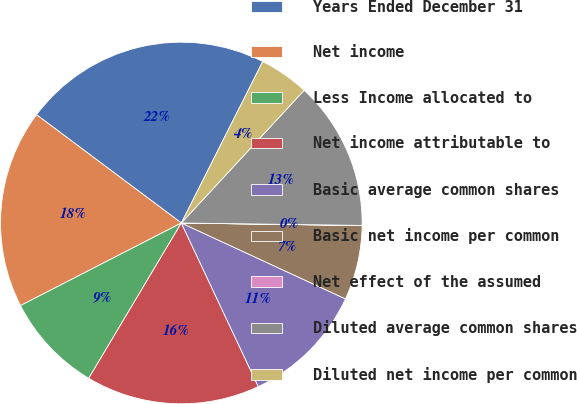Convert chart to OTSL. <chart><loc_0><loc_0><loc_500><loc_500><pie_chart><fcel>Years Ended December 31<fcel>Net income<fcel>Less Income allocated to<fcel>Net income attributable to<fcel>Basic average common shares<fcel>Basic net income per common<fcel>Net effect of the assumed<fcel>Diluted average common shares<fcel>Diluted net income per common<nl><fcel>22.21%<fcel>17.77%<fcel>8.89%<fcel>15.55%<fcel>11.11%<fcel>6.67%<fcel>0.01%<fcel>13.33%<fcel>4.45%<nl></chart> 